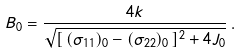Convert formula to latex. <formula><loc_0><loc_0><loc_500><loc_500>B _ { 0 } = \frac { 4 k } { \sqrt { [ \, ( \sigma _ { 1 1 } ) _ { 0 } - ( \sigma _ { 2 2 } ) _ { 0 } \, ] ^ { 2 } + 4 J _ { 0 } } } \, .</formula> 